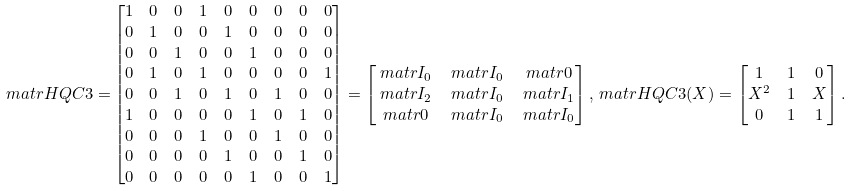<formula> <loc_0><loc_0><loc_500><loc_500>\ m a t r H Q C { 3 } = & \begin{bmatrix} 1 & 0 & 0 & 1 & 0 & 0 & 0 & 0 & 0 \\ 0 & 1 & 0 & 0 & 1 & 0 & 0 & 0 & 0 \\ 0 & 0 & 1 & 0 & 0 & 1 & 0 & 0 & 0 \\ 0 & 1 & 0 & 1 & 0 & 0 & 0 & 0 & 1 \\ 0 & 0 & 1 & 0 & 1 & 0 & 1 & 0 & 0 \\ 1 & 0 & 0 & 0 & 0 & 1 & 0 & 1 & 0 \\ 0 & 0 & 0 & 1 & 0 & 0 & 1 & 0 & 0 \\ 0 & 0 & 0 & 0 & 1 & 0 & 0 & 1 & 0 \\ 0 & 0 & 0 & 0 & 0 & 1 & 0 & 0 & 1 \end{bmatrix} = \begin{bmatrix} \ m a t r { I } _ { 0 } & \ m a t r { I } _ { 0 } & \ m a t r { 0 } \\ \ m a t r { I } _ { 2 } & \ m a t r { I } _ { 0 } & \ m a t r { I } _ { 1 } \\ \ m a t r { 0 } & \ m a t r { I } _ { 0 } & \ m a t r { I } _ { 0 } \end{bmatrix} , \ m a t r H Q C { 3 } ( X ) = \begin{bmatrix} 1 & 1 & 0 \\ X ^ { 2 } & 1 & X \\ 0 & 1 & 1 \end{bmatrix} .</formula> 